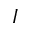Convert formula to latex. <formula><loc_0><loc_0><loc_500><loc_500>{ I }</formula> 